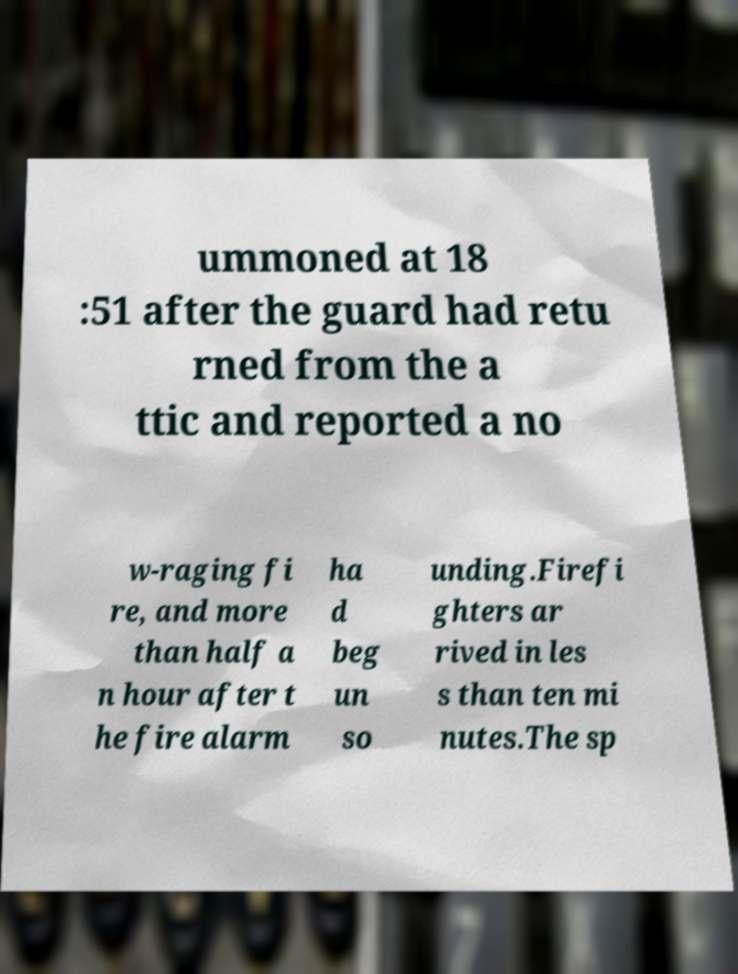Please identify and transcribe the text found in this image. ummoned at 18 :51 after the guard had retu rned from the a ttic and reported a no w-raging fi re, and more than half a n hour after t he fire alarm ha d beg un so unding.Firefi ghters ar rived in les s than ten mi nutes.The sp 